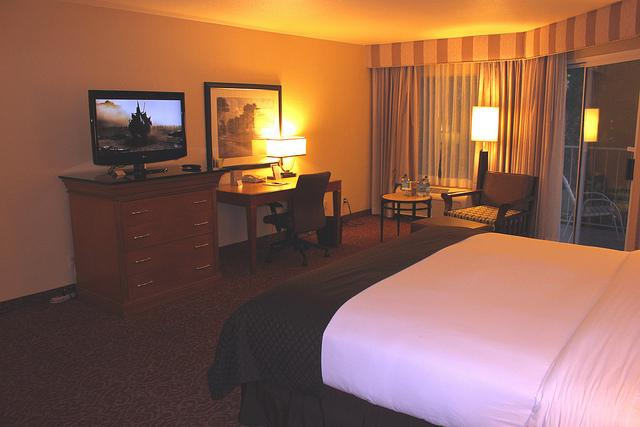What are in the bottles on the right? Please explain your reasoning. water. The bottles have water. 